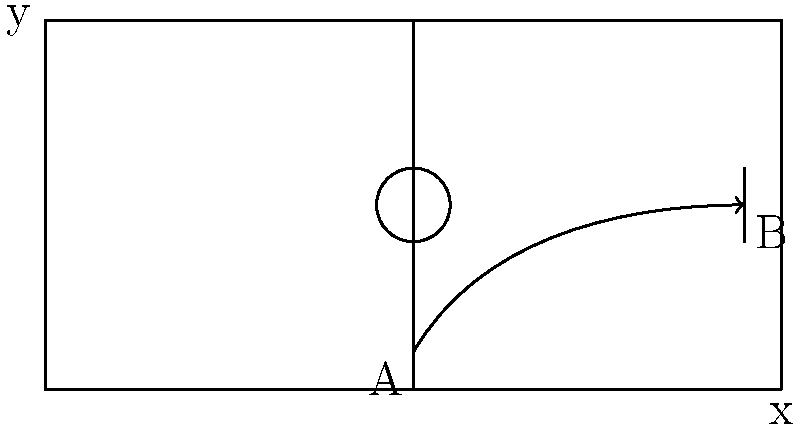In the legendary 1991 Danish Superliga match against FC Copenhagen, Brøndby IF's Kim Vilfort scored a spectacular goal from point A. If the ball's trajectory followed the path shown in the diagram, which mathematical function best describes the ball's path? To determine the mathematical function that best describes the ball's trajectory, let's analyze the path step-by-step:

1. The ball starts at point A, near the ground, and ends at point B, the goal.

2. The path of the ball is curved, starting with a steep upward angle and gradually leveling off as it approaches the goal.

3. The trajectory is smooth and continuous, without any sharp turns or breaks.

4. The curve is asymmetrical, with a steeper rise at the beginning and a more gradual descent towards the end.

5. This type of curve is characteristic of a parabola, which is represented by a quadratic function.

6. However, the asymmetry of the curve suggests that a simple quadratic function ($y = ax^2 + bx + c$) may not be the best fit.

7. A more accurate representation would be a cubic function, which can account for the asymmetry in the curve.

8. The general form of a cubic function is:

   $$y = ax^3 + bx^2 + cx + d$$

   where $a$, $b$, $c$, and $d$ are constants.

9. This cubic function allows for the initial steep ascent, the gradual leveling off, and the asymmetrical nature of the trajectory.

Therefore, the mathematical function that best describes the ball's path in Kim Vilfort's legendary goal is a cubic function.
Answer: Cubic function 